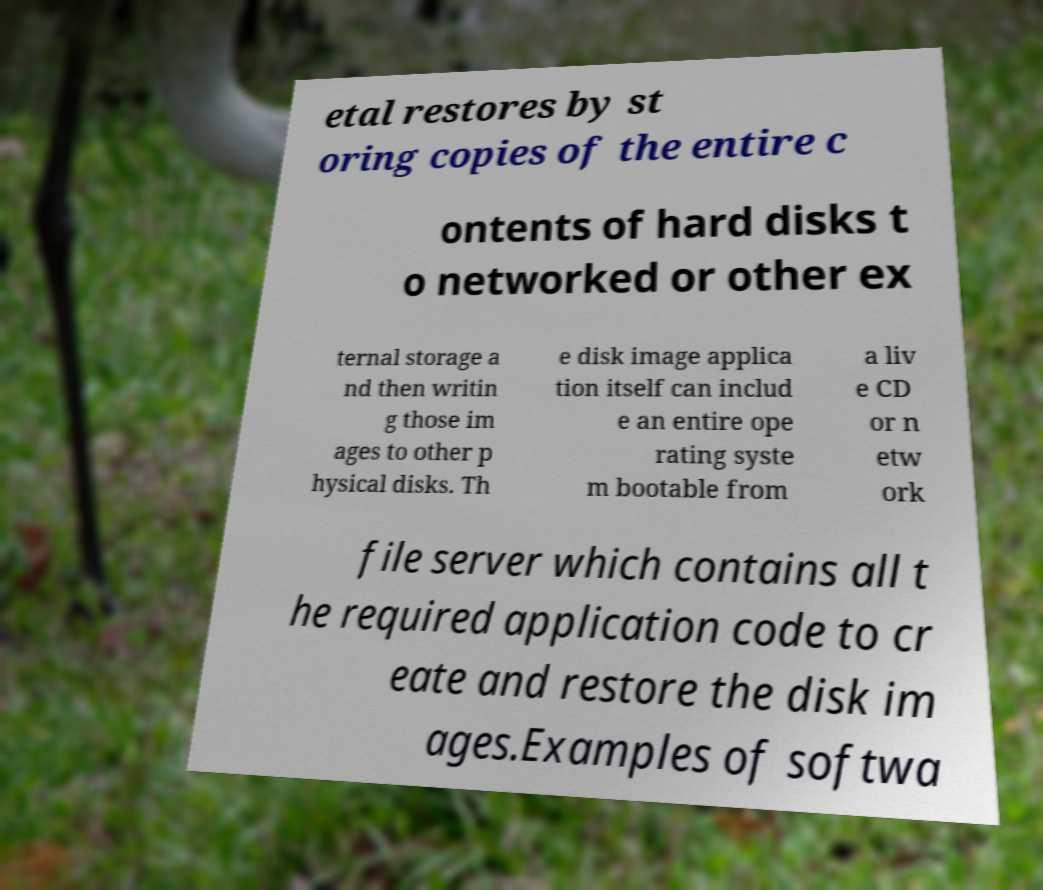For documentation purposes, I need the text within this image transcribed. Could you provide that? etal restores by st oring copies of the entire c ontents of hard disks t o networked or other ex ternal storage a nd then writin g those im ages to other p hysical disks. Th e disk image applica tion itself can includ e an entire ope rating syste m bootable from a liv e CD or n etw ork file server which contains all t he required application code to cr eate and restore the disk im ages.Examples of softwa 